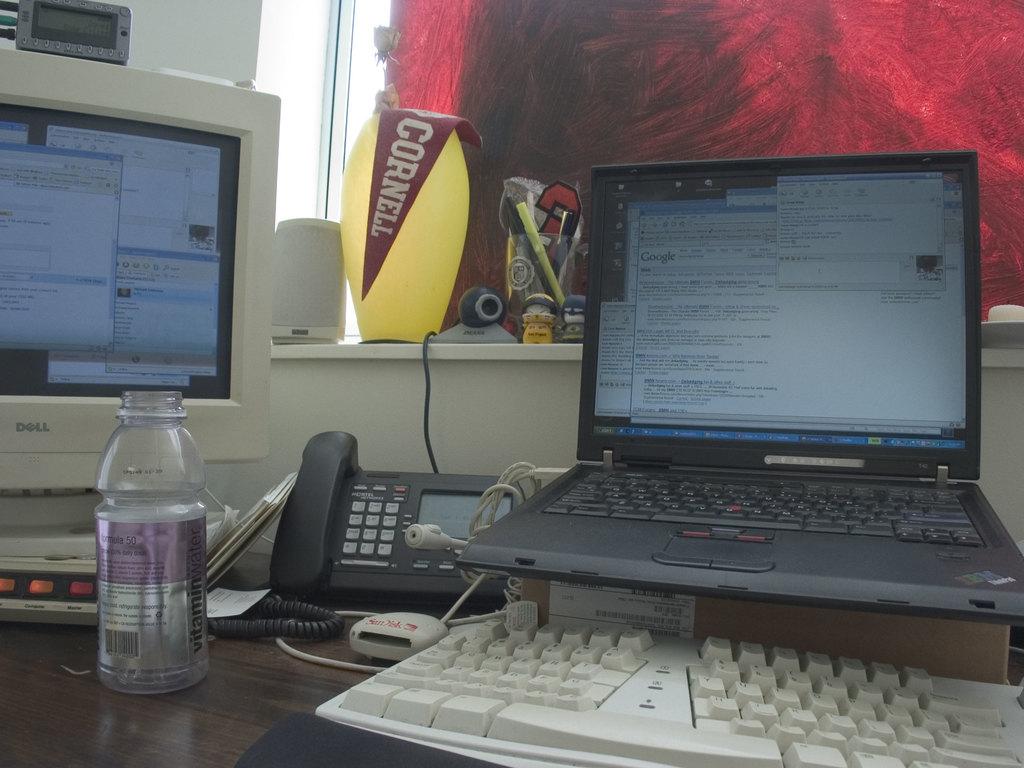What brand of water is this?
Your answer should be very brief. Vitamin water. 